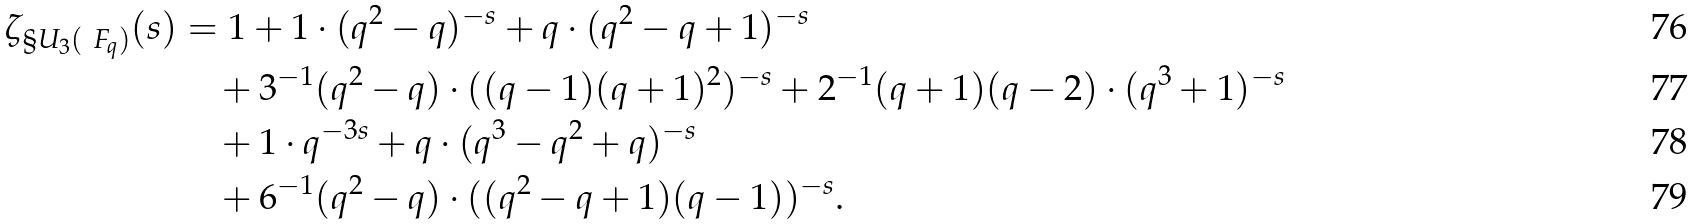<formula> <loc_0><loc_0><loc_500><loc_500>\zeta _ { \S U _ { 3 } ( \ F _ { q } ) } ( s ) & = 1 + 1 \cdot ( q ^ { 2 } - q ) ^ { - s } + q \cdot ( q ^ { 2 } - q + 1 ) ^ { - s } \\ & \quad + 3 ^ { - 1 } ( q ^ { 2 } - q ) \cdot ( ( q - 1 ) ( q + 1 ) ^ { 2 } ) ^ { - s } + 2 ^ { - 1 } ( q + 1 ) ( q - 2 ) \cdot ( q ^ { 3 } + 1 ) ^ { - s } \\ & \quad + 1 \cdot q ^ { - 3 s } + q \cdot ( q ^ { 3 } - q ^ { 2 } + q ) ^ { - s } \\ & \quad + 6 ^ { - 1 } ( q ^ { 2 } - q ) \cdot ( ( q ^ { 2 } - q + 1 ) ( q - 1 ) ) ^ { - s } .</formula> 